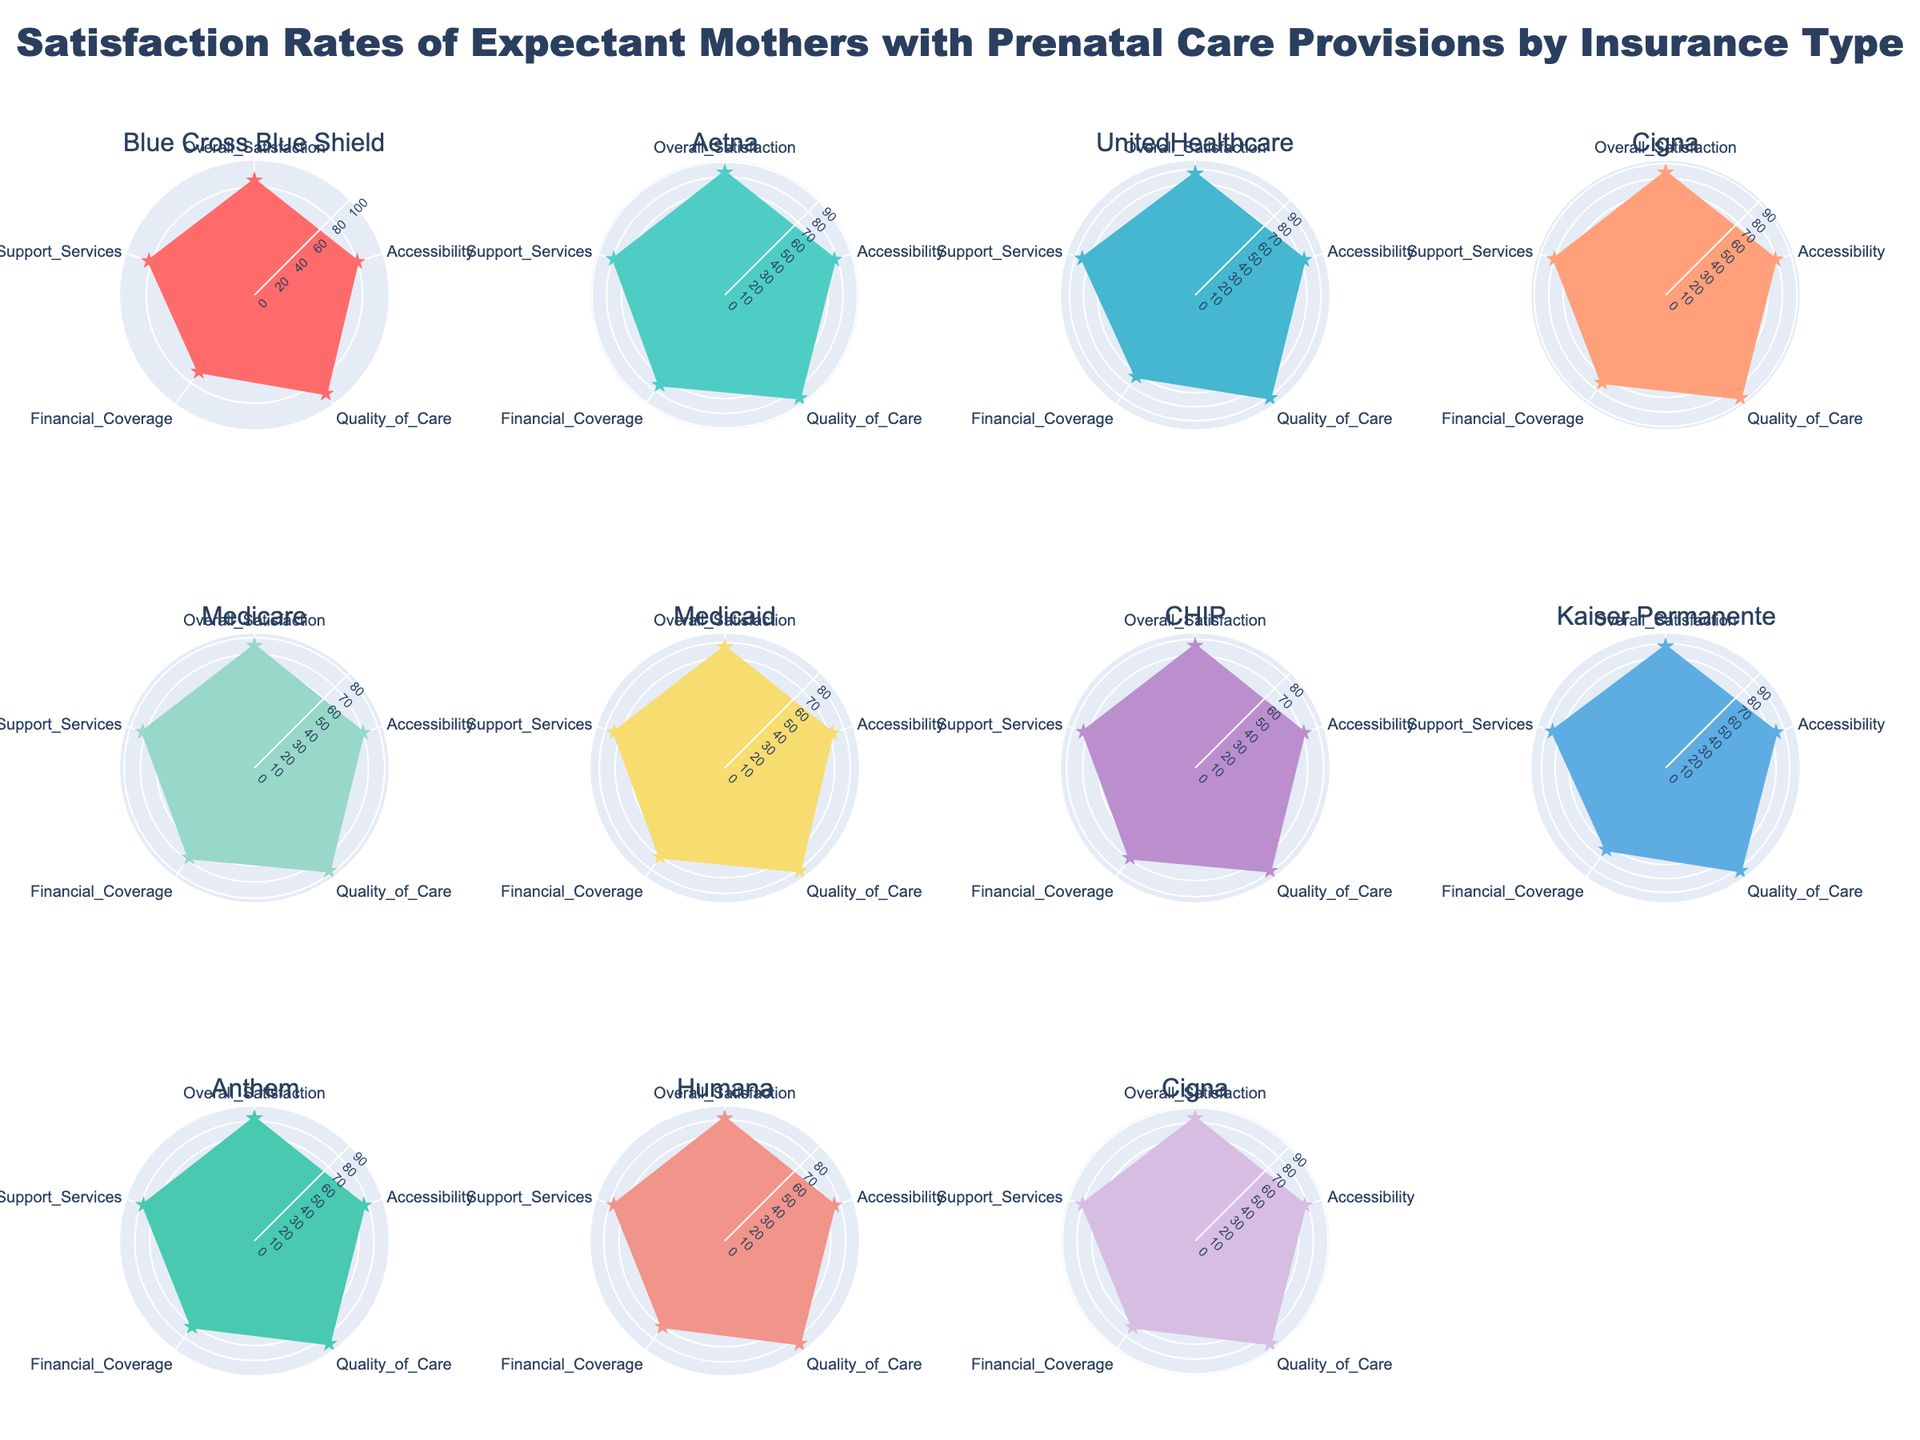Which insurance type company has the highest overall satisfaction rate? Identify the subplot with the highest value on the "Overall Satisfaction" axis. Kaiser Permanente has the highest overall satisfaction rating of 88.
Answer: Kaiser Permanente What is the average quality of care rating for all companies? Sum the quality of care ratings for all companies (90 + 86 + 91 + 87 + 78 + 81 + 79 + 92 + 85 + 84 + 86 = 939), then divide by the number of companies (11). The average is 939 / 11 = 85.36.
Answer: 85.36 Which company has the lowest accessibility rating? Identify the subplot with the lowest value on the "Accessibility" axis. Medicare has the lowest accessibility rating of 70.
Answer: Medicare How does financial coverage compare between private and public insurance types? Compare the average financial coverage ratings for private (Aetna, Blue Cross Blue Shield, Cigna, UnitedHealthcare: (70+75+74+72)/4 = 72.75) and public insurance types (Medicare, Medicaid, CHIP: (68+70+69)/3 = 69). Private insurance offers better financial coverage on average.
Answer: Private > Public Which company under public insurance has the highest support services rating? Compare the support services ratings among public insurance companies (Medicare, Medicaid, CHIP: 72, 74, 73). Medicaid has the highest support services rating of 74.
Answer: Medicaid 